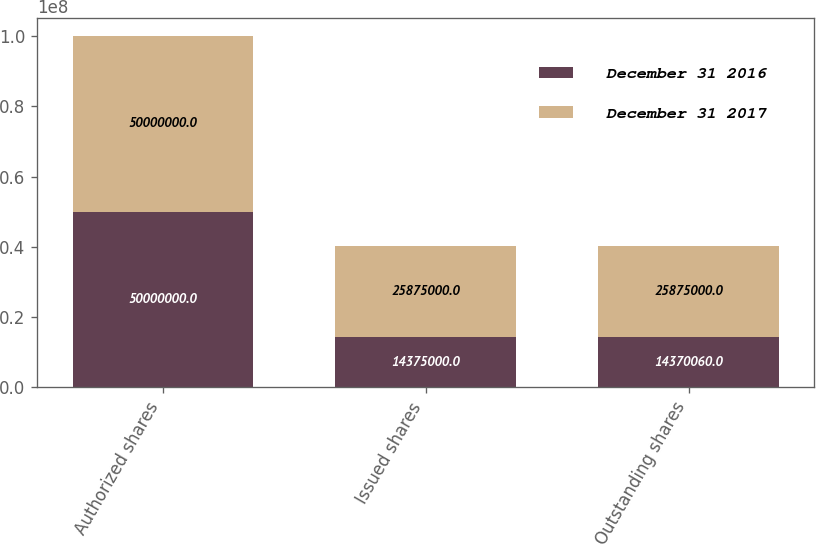Convert chart. <chart><loc_0><loc_0><loc_500><loc_500><stacked_bar_chart><ecel><fcel>Authorized shares<fcel>Issued shares<fcel>Outstanding shares<nl><fcel>December 31 2016<fcel>5e+07<fcel>1.4375e+07<fcel>1.43701e+07<nl><fcel>December 31 2017<fcel>5e+07<fcel>2.5875e+07<fcel>2.5875e+07<nl></chart> 